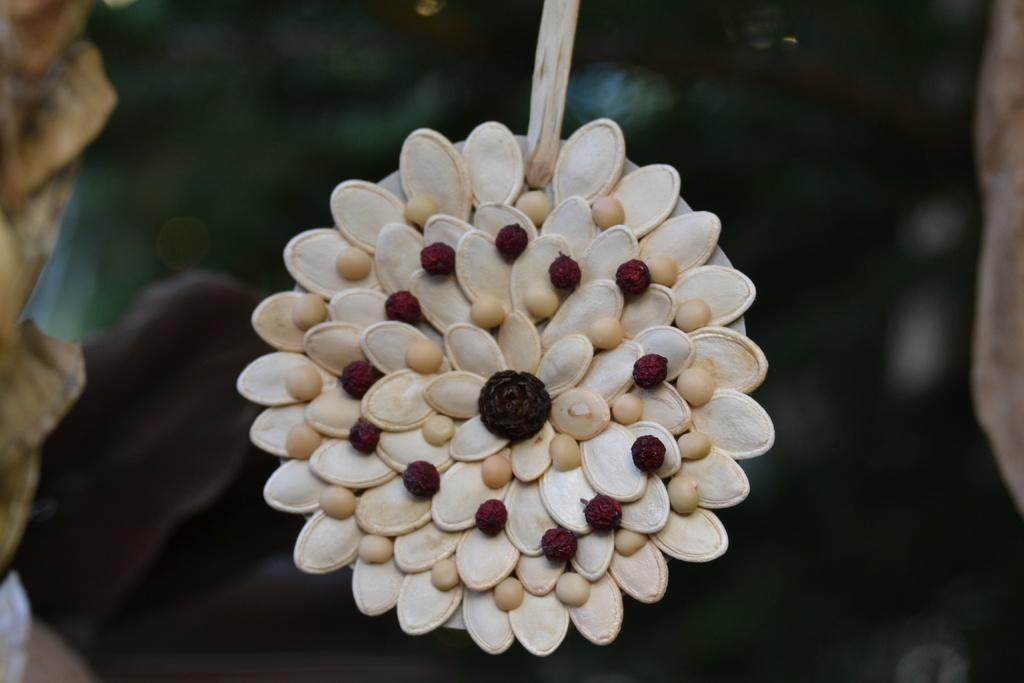How would you summarize this image in a sentence or two? In this picture we can see seeds arranged in a flower shape. There is a blur background. 